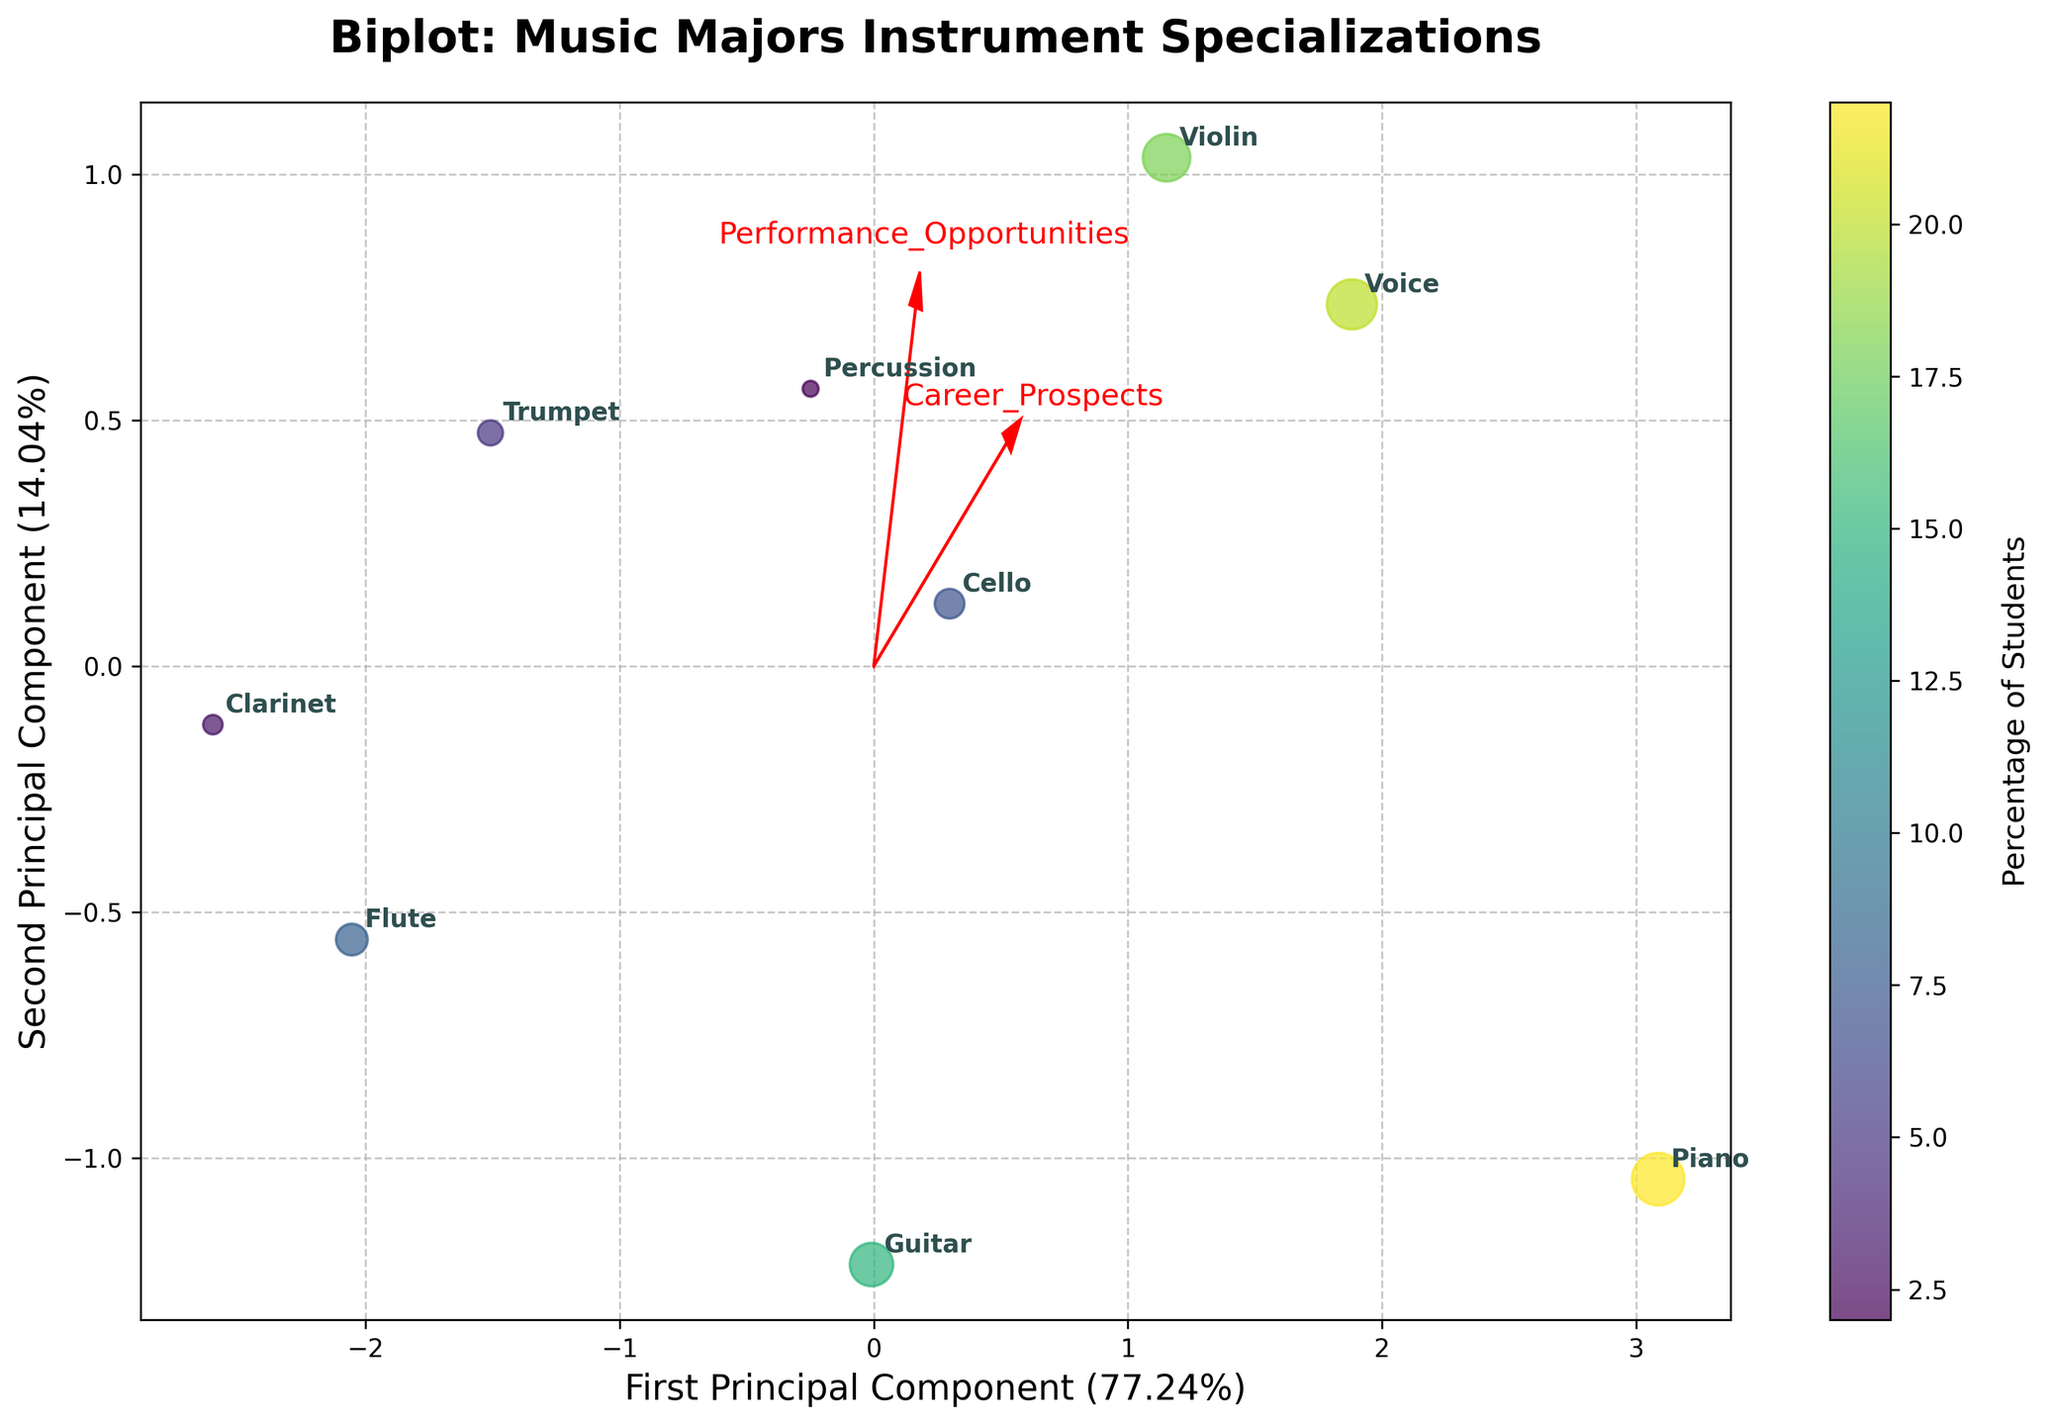what's the percentage of students majoring in Piano? Look for the Piano point on the plot and check the color legend to estimate the percentage. Piano has a high size of 22.
Answer: 22% Which instrument has the highest Teaching Potential? Locate the feature vector for Teaching Potential and see which instrument data point aligns closest with it; Piano stands out here.
Answer: Piano Are Career Prospects and Performance Opportunities correlated? Observe the directions of the feature vectors for Career Prospects and Performance Opportunities; they are closely aligned, suggesting strong correlation.
Answer: Yes Which instrument has the lowest Composition Demand score? Look for the Composition Demand feature vector and check which instrument is farthest from it; Trumpet appears the furthest.
Answer: Trumpet What is the title of the chart? Read the bold text at the top of the plot; it serves as the title.
Answer: Biplot: Music Majors Instrument Specializations Which instrument specialization has fewer students, Flute or Percussion? Check the sizes of the data points for Flute and Percussion—Flute's dot is larger.
Answer: Percussion What is the significance of the length and direction of the red arrows on the plot? The red arrows represent the importance and direction of each feature; longer arrows indicate a stronger influence on the principal components.
Answer: Importance and direction How much variance is captured by the first principal component? Read the explained variance percentage labeled along the x-axis.
Answer: Around 52% Which two instruments have the most similar prospect according to PCA? Observe the plot to see which points are closest to each other; Violin and Voice appear closest.
Answer: Violin and Voice 